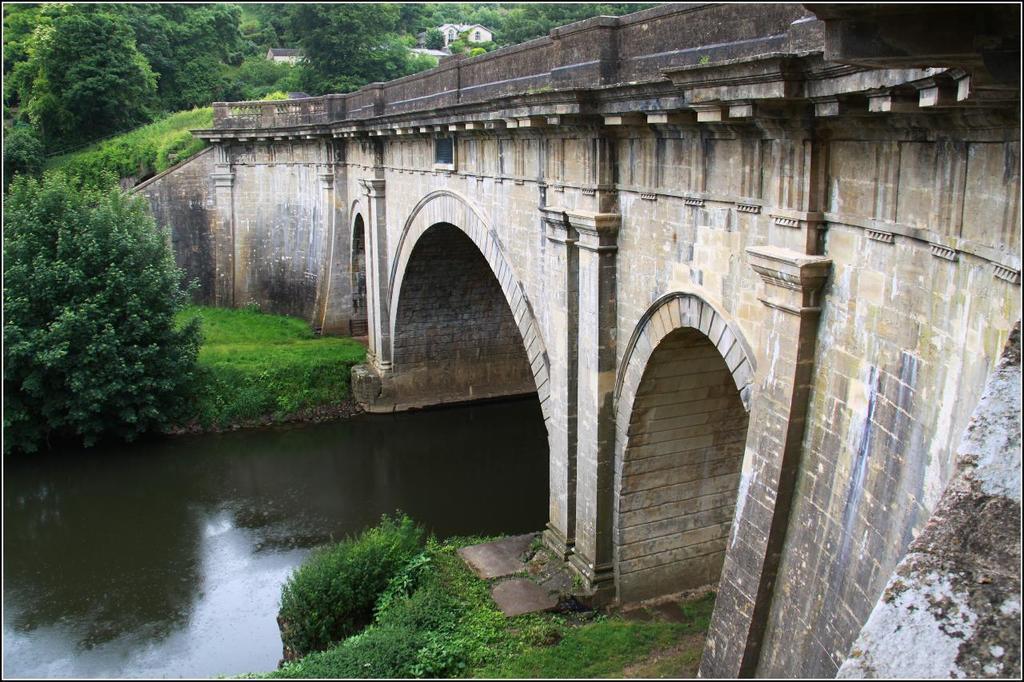Please provide a concise description of this image. In this image there is a bridge on the right side, under the bridge there are some trees and water, at the top there are some trees visible. 